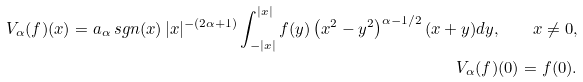<formula> <loc_0><loc_0><loc_500><loc_500>V _ { \alpha } ( f ) ( x ) = a _ { \alpha } \, s g n ( x ) \, | x | ^ { - ( 2 \alpha + 1 ) } \int ^ { | x | } _ { - | x | } f ( y ) \left ( x ^ { 2 } - y ^ { 2 } \right ) ^ { \alpha - 1 / 2 } ( x + y ) d y , \quad x \neq 0 , \\ V _ { \alpha } ( f ) ( 0 ) = f ( 0 ) .</formula> 